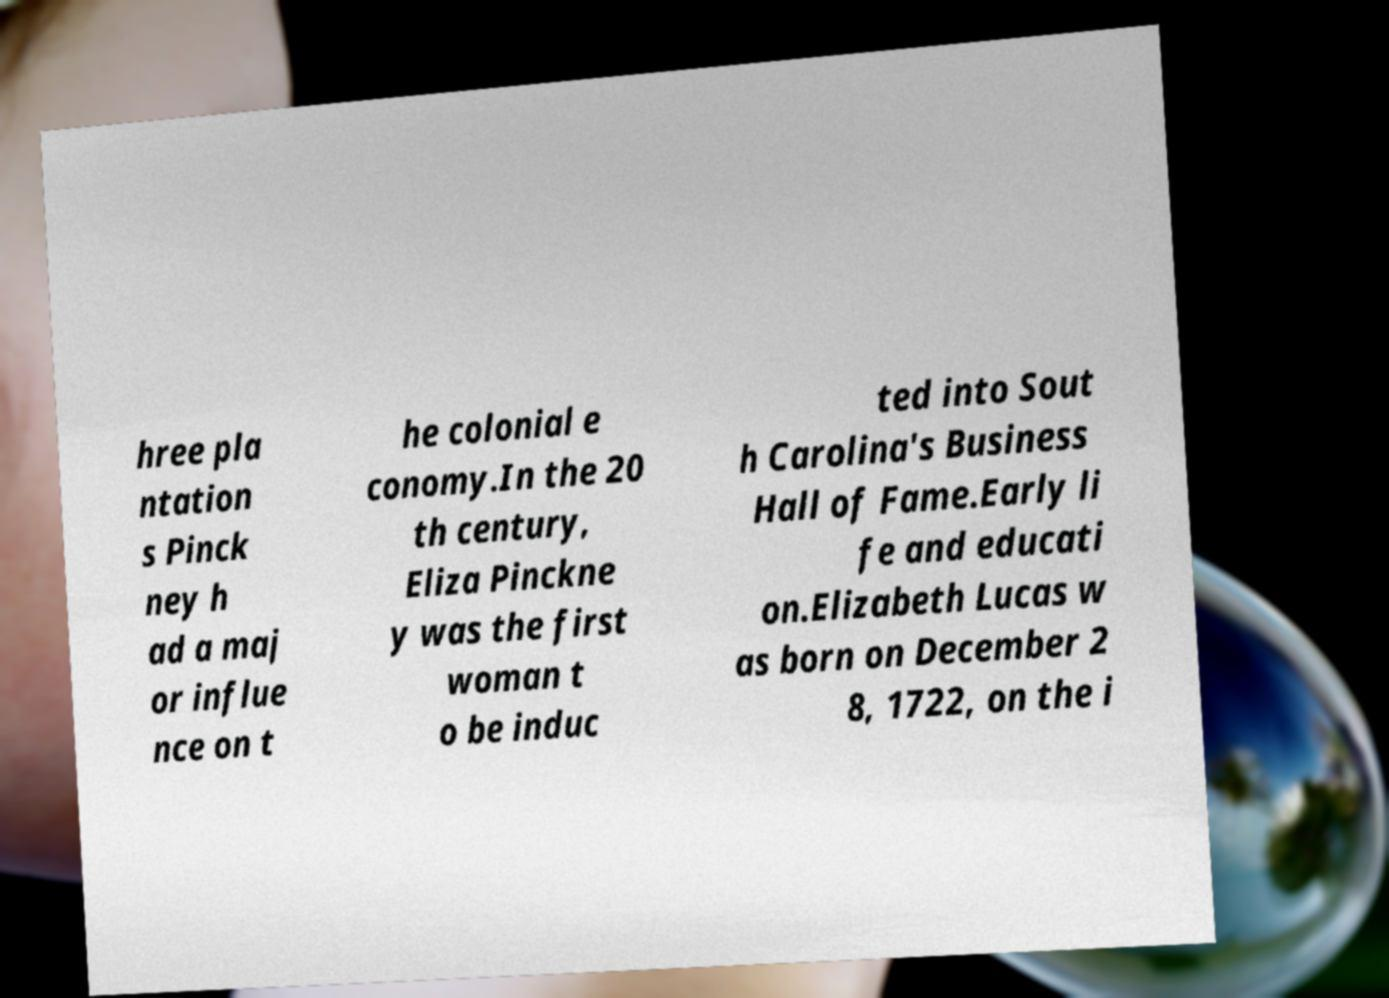Please identify and transcribe the text found in this image. hree pla ntation s Pinck ney h ad a maj or influe nce on t he colonial e conomy.In the 20 th century, Eliza Pinckne y was the first woman t o be induc ted into Sout h Carolina's Business Hall of Fame.Early li fe and educati on.Elizabeth Lucas w as born on December 2 8, 1722, on the i 